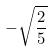Convert formula to latex. <formula><loc_0><loc_0><loc_500><loc_500>- \sqrt { \frac { 2 } { 5 } }</formula> 